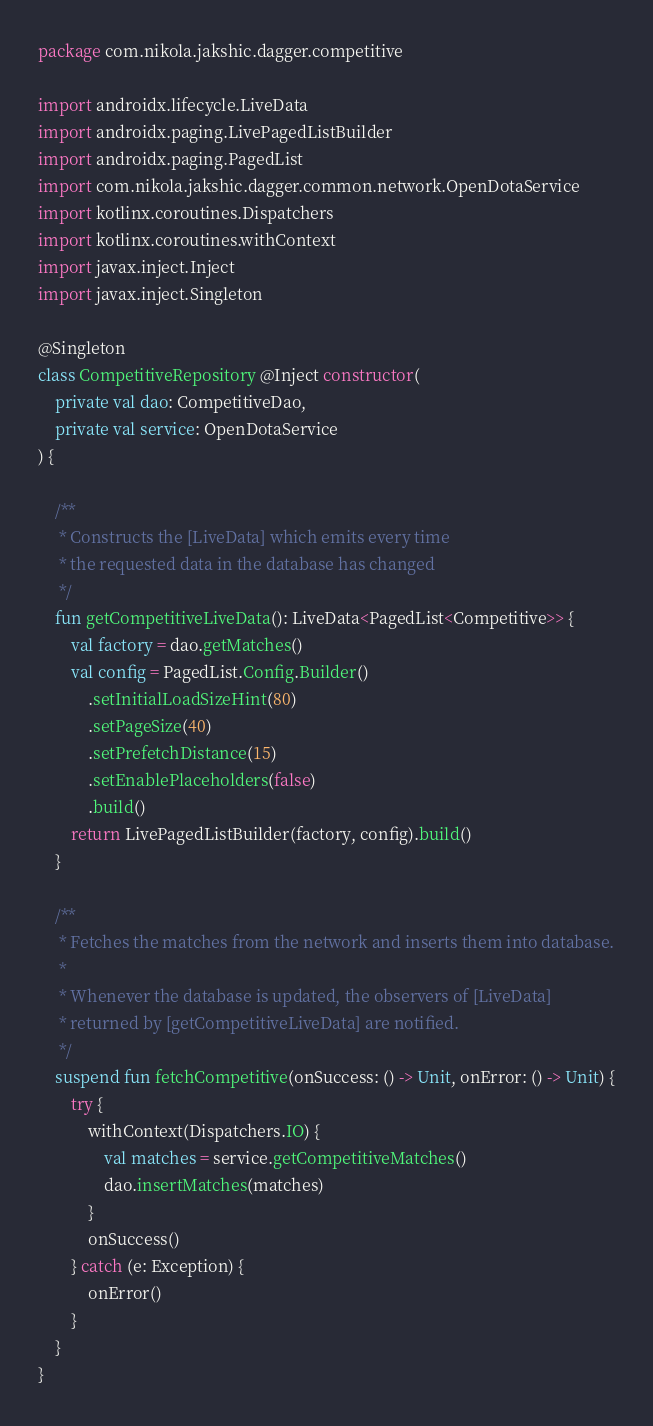Convert code to text. <code><loc_0><loc_0><loc_500><loc_500><_Kotlin_>package com.nikola.jakshic.dagger.competitive

import androidx.lifecycle.LiveData
import androidx.paging.LivePagedListBuilder
import androidx.paging.PagedList
import com.nikola.jakshic.dagger.common.network.OpenDotaService
import kotlinx.coroutines.Dispatchers
import kotlinx.coroutines.withContext
import javax.inject.Inject
import javax.inject.Singleton

@Singleton
class CompetitiveRepository @Inject constructor(
    private val dao: CompetitiveDao,
    private val service: OpenDotaService
) {

    /**
     * Constructs the [LiveData] which emits every time
     * the requested data in the database has changed
     */
    fun getCompetitiveLiveData(): LiveData<PagedList<Competitive>> {
        val factory = dao.getMatches()
        val config = PagedList.Config.Builder()
            .setInitialLoadSizeHint(80)
            .setPageSize(40)
            .setPrefetchDistance(15)
            .setEnablePlaceholders(false)
            .build()
        return LivePagedListBuilder(factory, config).build()
    }

    /**
     * Fetches the matches from the network and inserts them into database.
     *
     * Whenever the database is updated, the observers of [LiveData]
     * returned by [getCompetitiveLiveData] are notified.
     */
    suspend fun fetchCompetitive(onSuccess: () -> Unit, onError: () -> Unit) {
        try {
            withContext(Dispatchers.IO) {
                val matches = service.getCompetitiveMatches()
                dao.insertMatches(matches)
            }
            onSuccess()
        } catch (e: Exception) {
            onError()
        }
    }
}</code> 